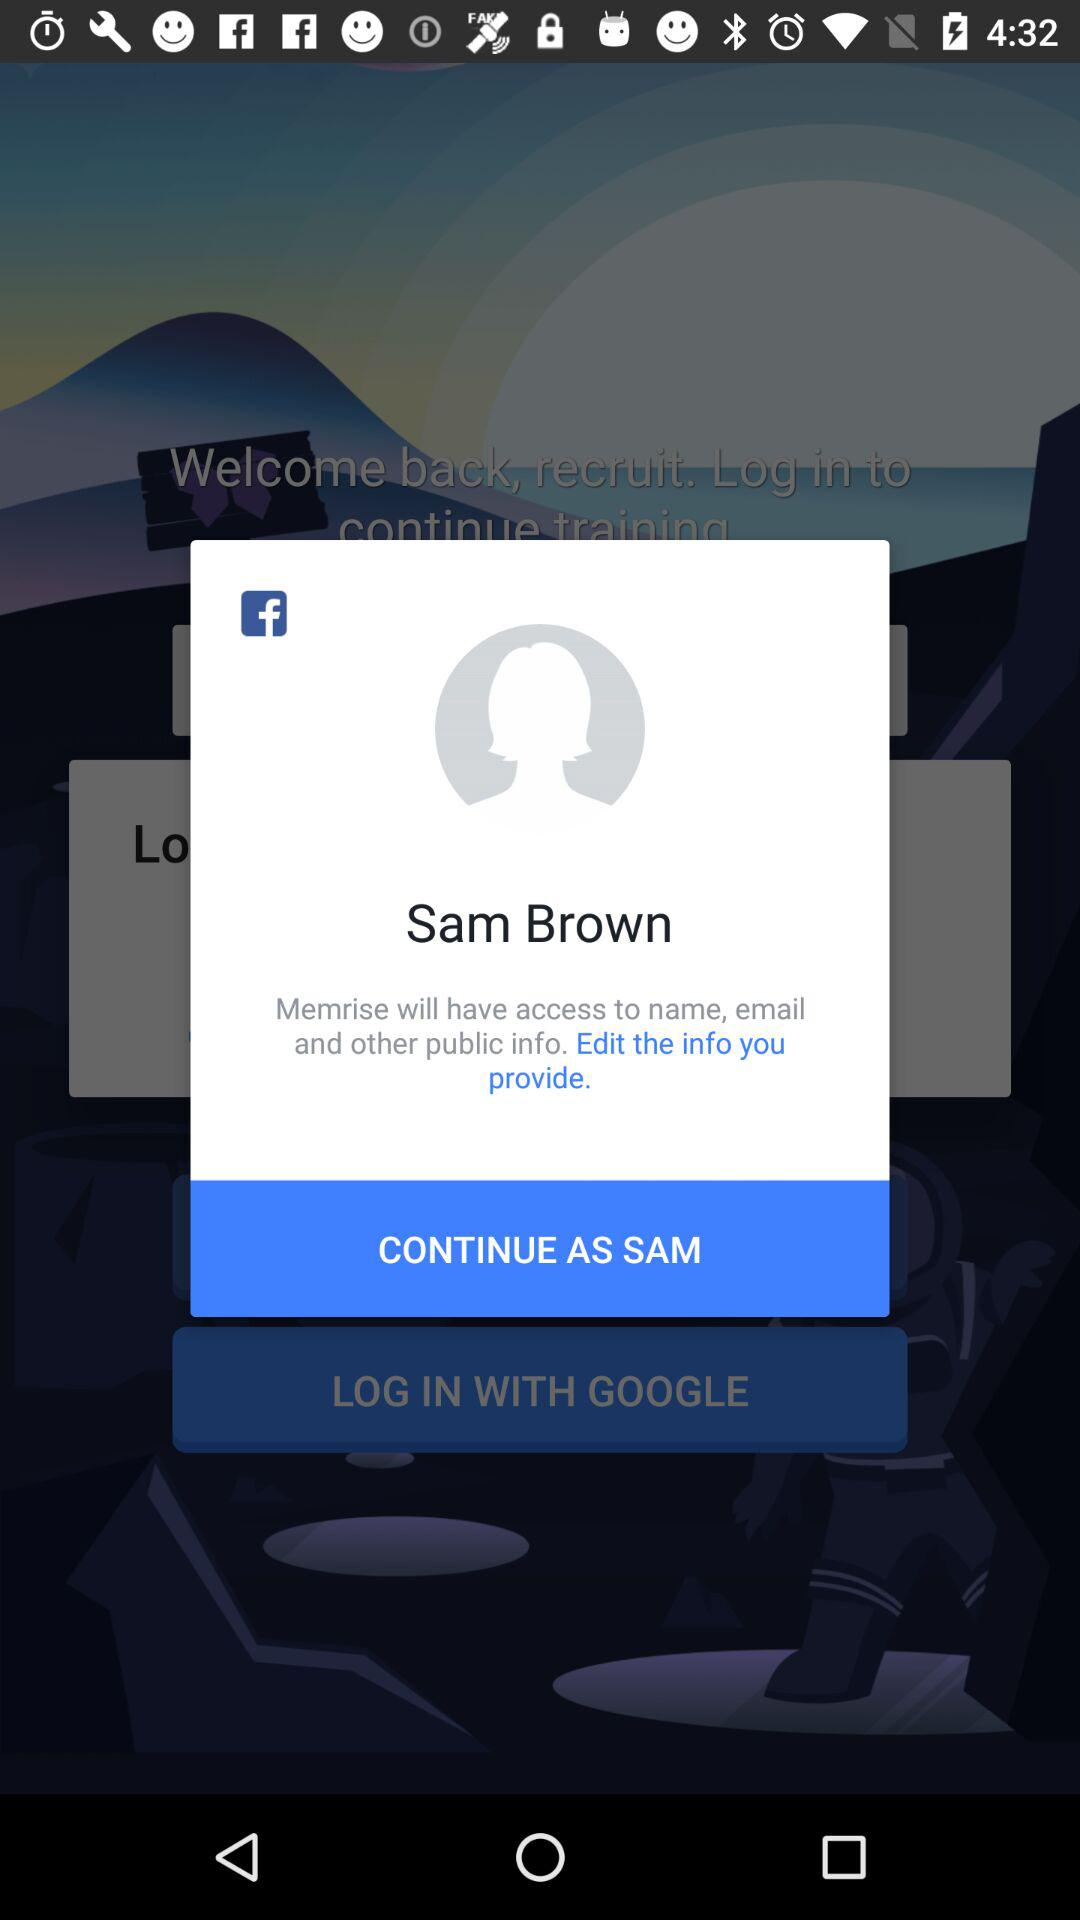How many public information types does Memrise have access to?
Answer the question using a single word or phrase. 3 